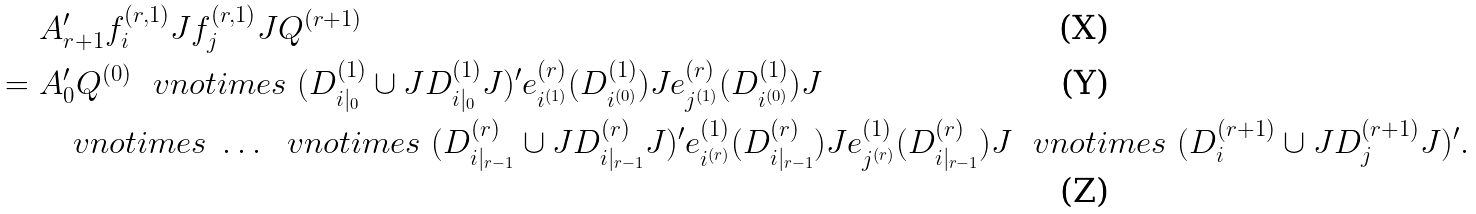<formula> <loc_0><loc_0><loc_500><loc_500>& \ A _ { r + 1 } ^ { \prime } f ^ { ( r , 1 ) } _ { i } J f ^ { ( r , 1 ) } _ { j } J Q ^ { ( r + 1 ) } \\ = & \ A _ { 0 } ^ { \prime } Q ^ { ( 0 ) } \ \ v n o t i m e s \ ( D ^ { ( 1 ) } _ { i | _ { 0 } } \cup J D ^ { ( 1 ) } _ { i | _ { 0 } } J ) ^ { \prime } e ^ { ( r ) } _ { i ^ { ( 1 ) } } ( D ^ { ( 1 ) } _ { i ^ { ( 0 ) } } ) J e ^ { ( r ) } _ { j ^ { ( 1 ) } } ( D ^ { ( 1 ) } _ { i ^ { ( 0 ) } } ) J \\ & \quad \ v n o t i m e s \ \dots \ \ v n o t i m e s \ ( D ^ { ( r ) } _ { i | _ { r - 1 } } \cup J D ^ { ( r ) } _ { i | _ { r - 1 } } J ) ^ { \prime } e ^ { ( 1 ) } _ { i ^ { ( r ) } } ( D ^ { ( r ) } _ { i | _ { r - 1 } } ) J e ^ { ( 1 ) } _ { j ^ { ( r ) } } ( D ^ { ( r ) } _ { i | _ { r - 1 } } ) J \ \ v n o t i m e s \ ( D ^ { ( r + 1 ) } _ { i } \cup J D ^ { ( r + 1 ) } _ { j } J ) ^ { \prime } .</formula> 